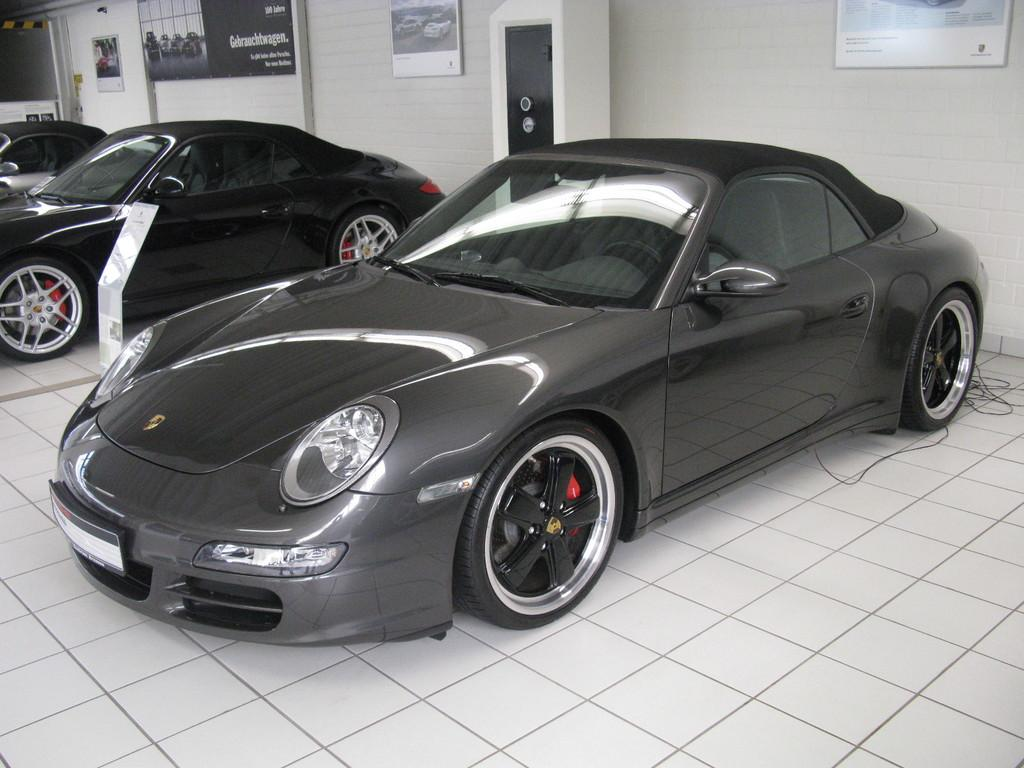What objects can be seen in the image? There are boards, vehicles, a locker, and other objects in the image. What is the surface on which the objects are placed or situated? There is a tile floor in the image. What is written on the boards in the image? Something is written on the boards, but the specific content is not mentioned in the facts. Where are the boards located in the image? The boards are on a wall in the image. What type of vehicles are visible in the image? The facts do not specify the type of vehicles in the image. What type of drug can be seen in the image? There is no drug present in the image. How many thumbs are visible in the image? There is no mention of thumbs in the image, so it is impossible to determine their number. 